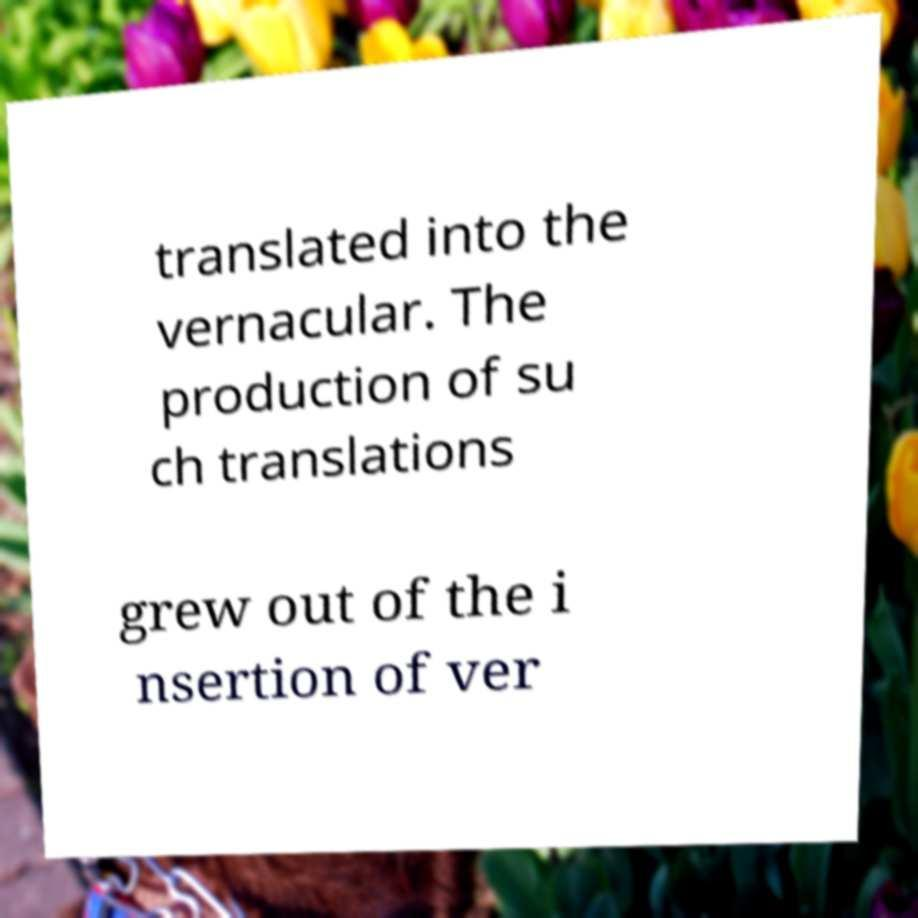Could you assist in decoding the text presented in this image and type it out clearly? translated into the vernacular. The production of su ch translations grew out of the i nsertion of ver 